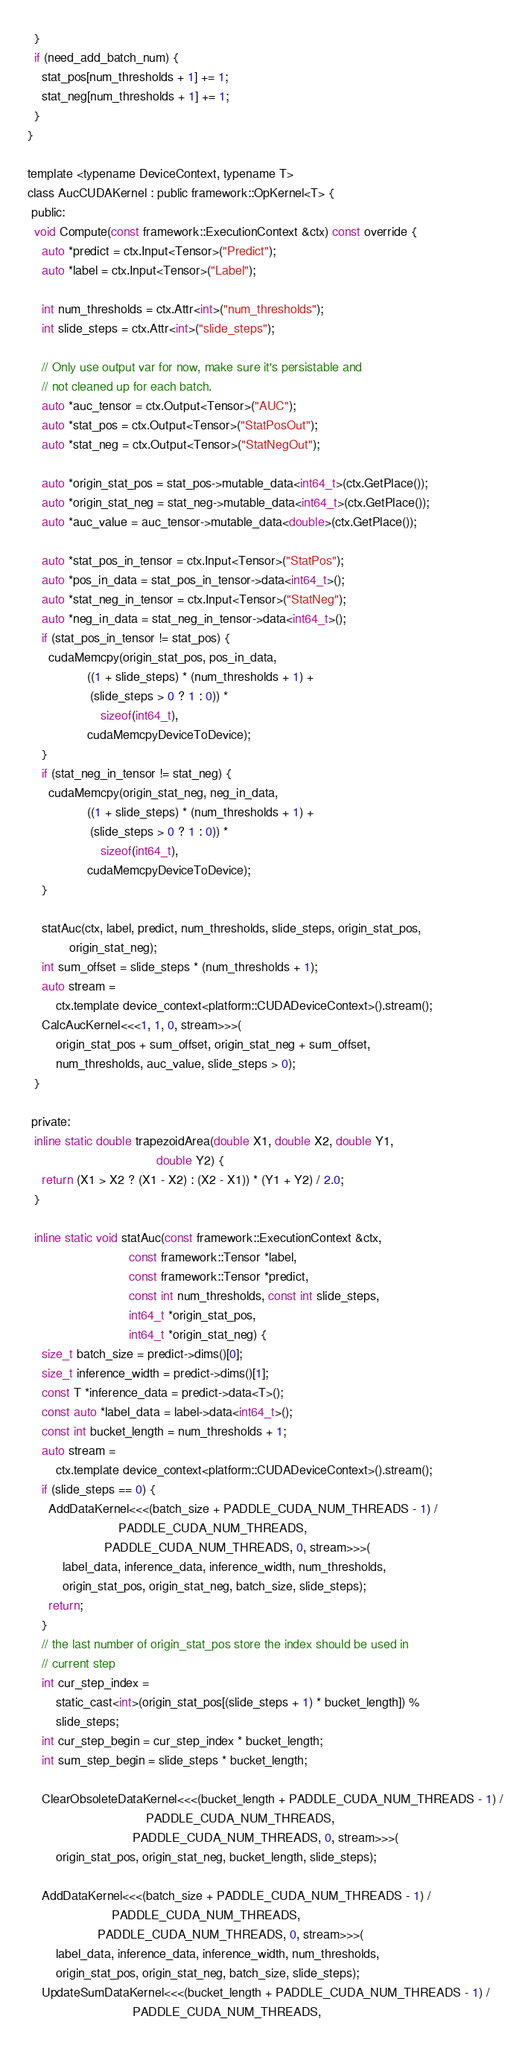Convert code to text. <code><loc_0><loc_0><loc_500><loc_500><_Cuda_>  }
  if (need_add_batch_num) {
    stat_pos[num_thresholds + 1] += 1;
    stat_neg[num_thresholds + 1] += 1;
  }
}

template <typename DeviceContext, typename T>
class AucCUDAKernel : public framework::OpKernel<T> {
 public:
  void Compute(const framework::ExecutionContext &ctx) const override {
    auto *predict = ctx.Input<Tensor>("Predict");
    auto *label = ctx.Input<Tensor>("Label");

    int num_thresholds = ctx.Attr<int>("num_thresholds");
    int slide_steps = ctx.Attr<int>("slide_steps");

    // Only use output var for now, make sure it's persistable and
    // not cleaned up for each batch.
    auto *auc_tensor = ctx.Output<Tensor>("AUC");
    auto *stat_pos = ctx.Output<Tensor>("StatPosOut");
    auto *stat_neg = ctx.Output<Tensor>("StatNegOut");

    auto *origin_stat_pos = stat_pos->mutable_data<int64_t>(ctx.GetPlace());
    auto *origin_stat_neg = stat_neg->mutable_data<int64_t>(ctx.GetPlace());
    auto *auc_value = auc_tensor->mutable_data<double>(ctx.GetPlace());

    auto *stat_pos_in_tensor = ctx.Input<Tensor>("StatPos");
    auto *pos_in_data = stat_pos_in_tensor->data<int64_t>();
    auto *stat_neg_in_tensor = ctx.Input<Tensor>("StatNeg");
    auto *neg_in_data = stat_neg_in_tensor->data<int64_t>();
    if (stat_pos_in_tensor != stat_pos) {
      cudaMemcpy(origin_stat_pos, pos_in_data,
                 ((1 + slide_steps) * (num_thresholds + 1) +
                  (slide_steps > 0 ? 1 : 0)) *
                     sizeof(int64_t),
                 cudaMemcpyDeviceToDevice);
    }
    if (stat_neg_in_tensor != stat_neg) {
      cudaMemcpy(origin_stat_neg, neg_in_data,
                 ((1 + slide_steps) * (num_thresholds + 1) +
                  (slide_steps > 0 ? 1 : 0)) *
                     sizeof(int64_t),
                 cudaMemcpyDeviceToDevice);
    }

    statAuc(ctx, label, predict, num_thresholds, slide_steps, origin_stat_pos,
            origin_stat_neg);
    int sum_offset = slide_steps * (num_thresholds + 1);
    auto stream =
        ctx.template device_context<platform::CUDADeviceContext>().stream();
    CalcAucKernel<<<1, 1, 0, stream>>>(
        origin_stat_pos + sum_offset, origin_stat_neg + sum_offset,
        num_thresholds, auc_value, slide_steps > 0);
  }

 private:
  inline static double trapezoidArea(double X1, double X2, double Y1,
                                     double Y2) {
    return (X1 > X2 ? (X1 - X2) : (X2 - X1)) * (Y1 + Y2) / 2.0;
  }

  inline static void statAuc(const framework::ExecutionContext &ctx,
                             const framework::Tensor *label,
                             const framework::Tensor *predict,
                             const int num_thresholds, const int slide_steps,
                             int64_t *origin_stat_pos,
                             int64_t *origin_stat_neg) {
    size_t batch_size = predict->dims()[0];
    size_t inference_width = predict->dims()[1];
    const T *inference_data = predict->data<T>();
    const auto *label_data = label->data<int64_t>();
    const int bucket_length = num_thresholds + 1;
    auto stream =
        ctx.template device_context<platform::CUDADeviceContext>().stream();
    if (slide_steps == 0) {
      AddDataKernel<<<(batch_size + PADDLE_CUDA_NUM_THREADS - 1) /
                          PADDLE_CUDA_NUM_THREADS,
                      PADDLE_CUDA_NUM_THREADS, 0, stream>>>(
          label_data, inference_data, inference_width, num_thresholds,
          origin_stat_pos, origin_stat_neg, batch_size, slide_steps);
      return;
    }
    // the last number of origin_stat_pos store the index should be used in
    // current step
    int cur_step_index =
        static_cast<int>(origin_stat_pos[(slide_steps + 1) * bucket_length]) %
        slide_steps;
    int cur_step_begin = cur_step_index * bucket_length;
    int sum_step_begin = slide_steps * bucket_length;

    ClearObsoleteDataKernel<<<(bucket_length + PADDLE_CUDA_NUM_THREADS - 1) /
                                  PADDLE_CUDA_NUM_THREADS,
                              PADDLE_CUDA_NUM_THREADS, 0, stream>>>(
        origin_stat_pos, origin_stat_neg, bucket_length, slide_steps);

    AddDataKernel<<<(batch_size + PADDLE_CUDA_NUM_THREADS - 1) /
                        PADDLE_CUDA_NUM_THREADS,
                    PADDLE_CUDA_NUM_THREADS, 0, stream>>>(
        label_data, inference_data, inference_width, num_thresholds,
        origin_stat_pos, origin_stat_neg, batch_size, slide_steps);
    UpdateSumDataKernel<<<(bucket_length + PADDLE_CUDA_NUM_THREADS - 1) /
                              PADDLE_CUDA_NUM_THREADS,</code> 